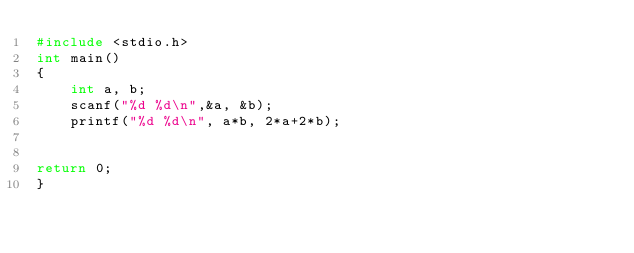<code> <loc_0><loc_0><loc_500><loc_500><_C_>#include <stdio.h>
int main()
{
    int a, b;
    scanf("%d %d\n",&a, &b);
    printf("%d %d\n", a*b, 2*a+2*b);
 
  
return 0;
}</code> 